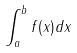<formula> <loc_0><loc_0><loc_500><loc_500>\int _ { a } ^ { b } f ( x ) d x</formula> 